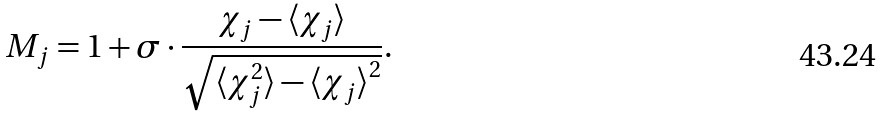<formula> <loc_0><loc_0><loc_500><loc_500>M _ { j } = 1 + \sigma \cdot \frac { \chi _ { j } - \langle \chi _ { j } \rangle } { \sqrt { \langle \chi _ { j } ^ { 2 } \rangle - { \langle \chi _ { j } \rangle } ^ { 2 } } } .</formula> 